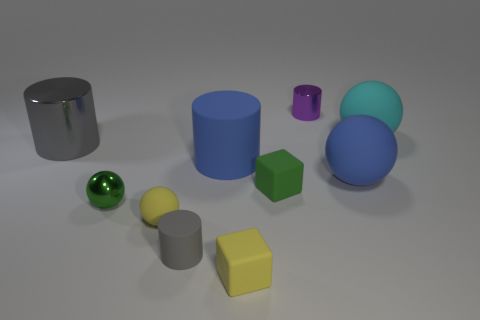Subtract all gray matte cylinders. How many cylinders are left? 3 Subtract 1 cylinders. How many cylinders are left? 3 Subtract all gray cylinders. How many cylinders are left? 2 Subtract all cylinders. How many objects are left? 6 Subtract all gray balls. How many green cubes are left? 1 Subtract all big purple rubber balls. Subtract all small purple metallic cylinders. How many objects are left? 9 Add 7 cyan matte spheres. How many cyan matte spheres are left? 8 Add 7 large rubber spheres. How many large rubber spheres exist? 9 Subtract 0 purple spheres. How many objects are left? 10 Subtract all gray cylinders. Subtract all blue balls. How many cylinders are left? 2 